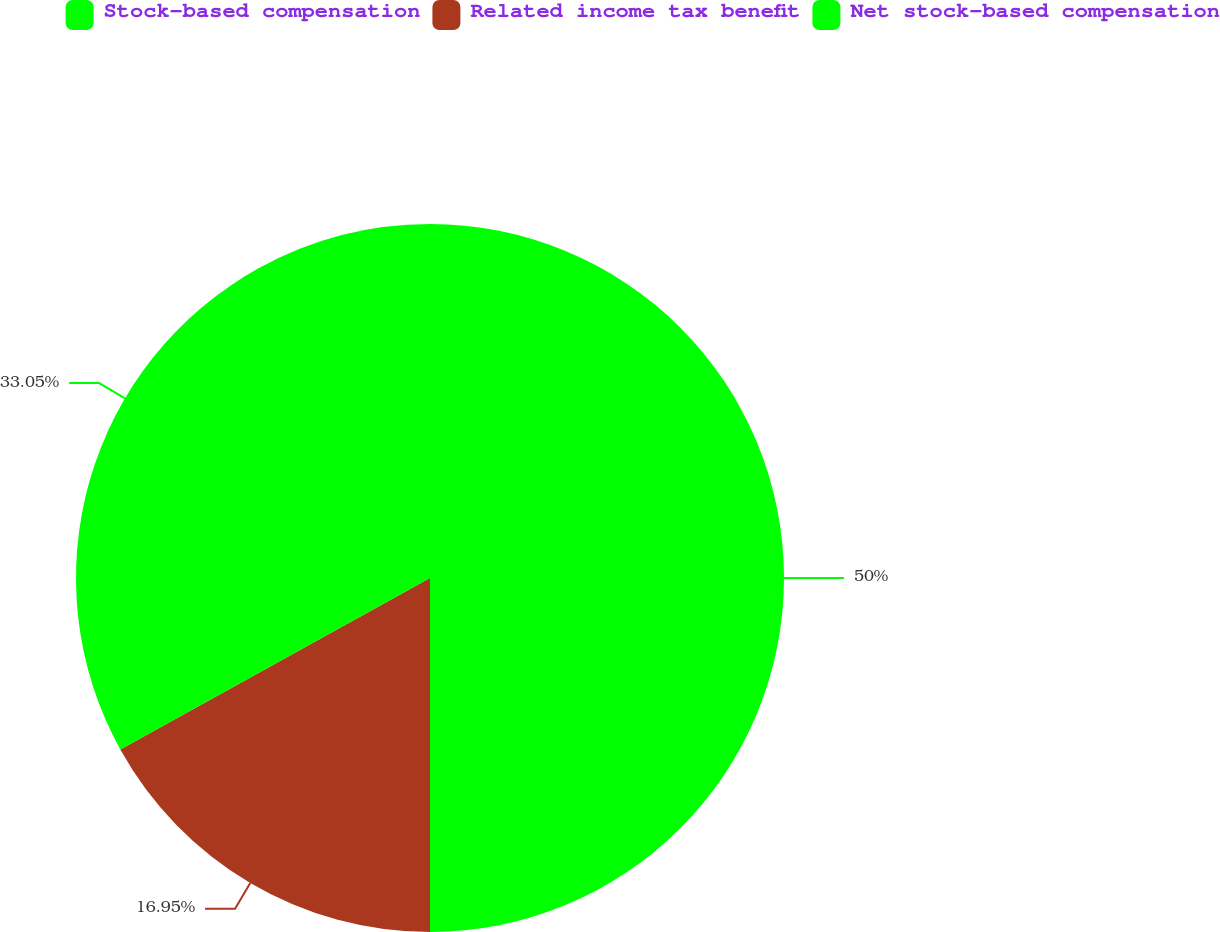<chart> <loc_0><loc_0><loc_500><loc_500><pie_chart><fcel>Stock-based compensation<fcel>Related income tax benefit<fcel>Net stock-based compensation<nl><fcel>50.0%<fcel>16.95%<fcel>33.05%<nl></chart> 